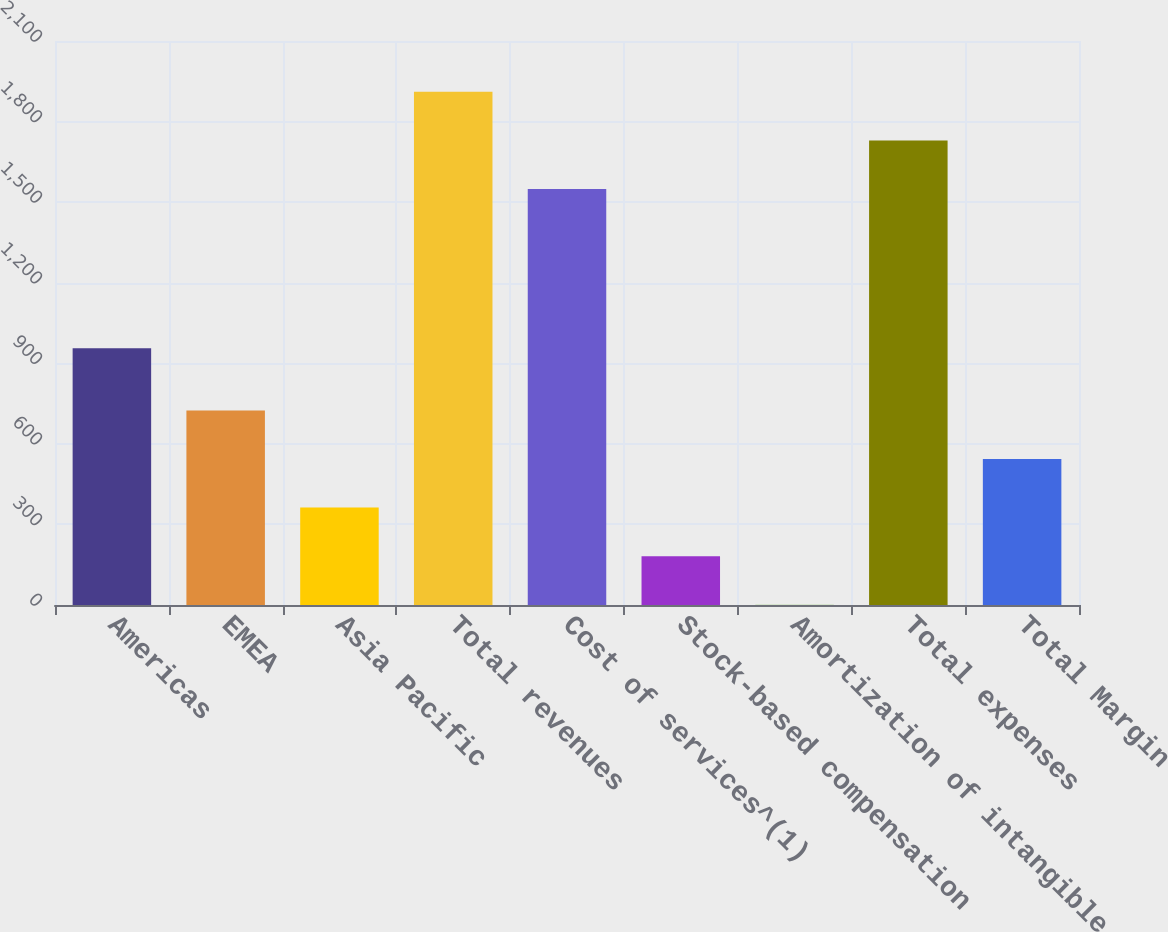<chart> <loc_0><loc_0><loc_500><loc_500><bar_chart><fcel>Americas<fcel>EMEA<fcel>Asia Pacific<fcel>Total revenues<fcel>Cost of services^(1)<fcel>Stock-based compensation<fcel>Amortization of intangible<fcel>Total expenses<fcel>Total Margin<nl><fcel>956<fcel>724.6<fcel>362.8<fcel>1910.8<fcel>1549<fcel>181.9<fcel>1<fcel>1729.9<fcel>543.7<nl></chart> 